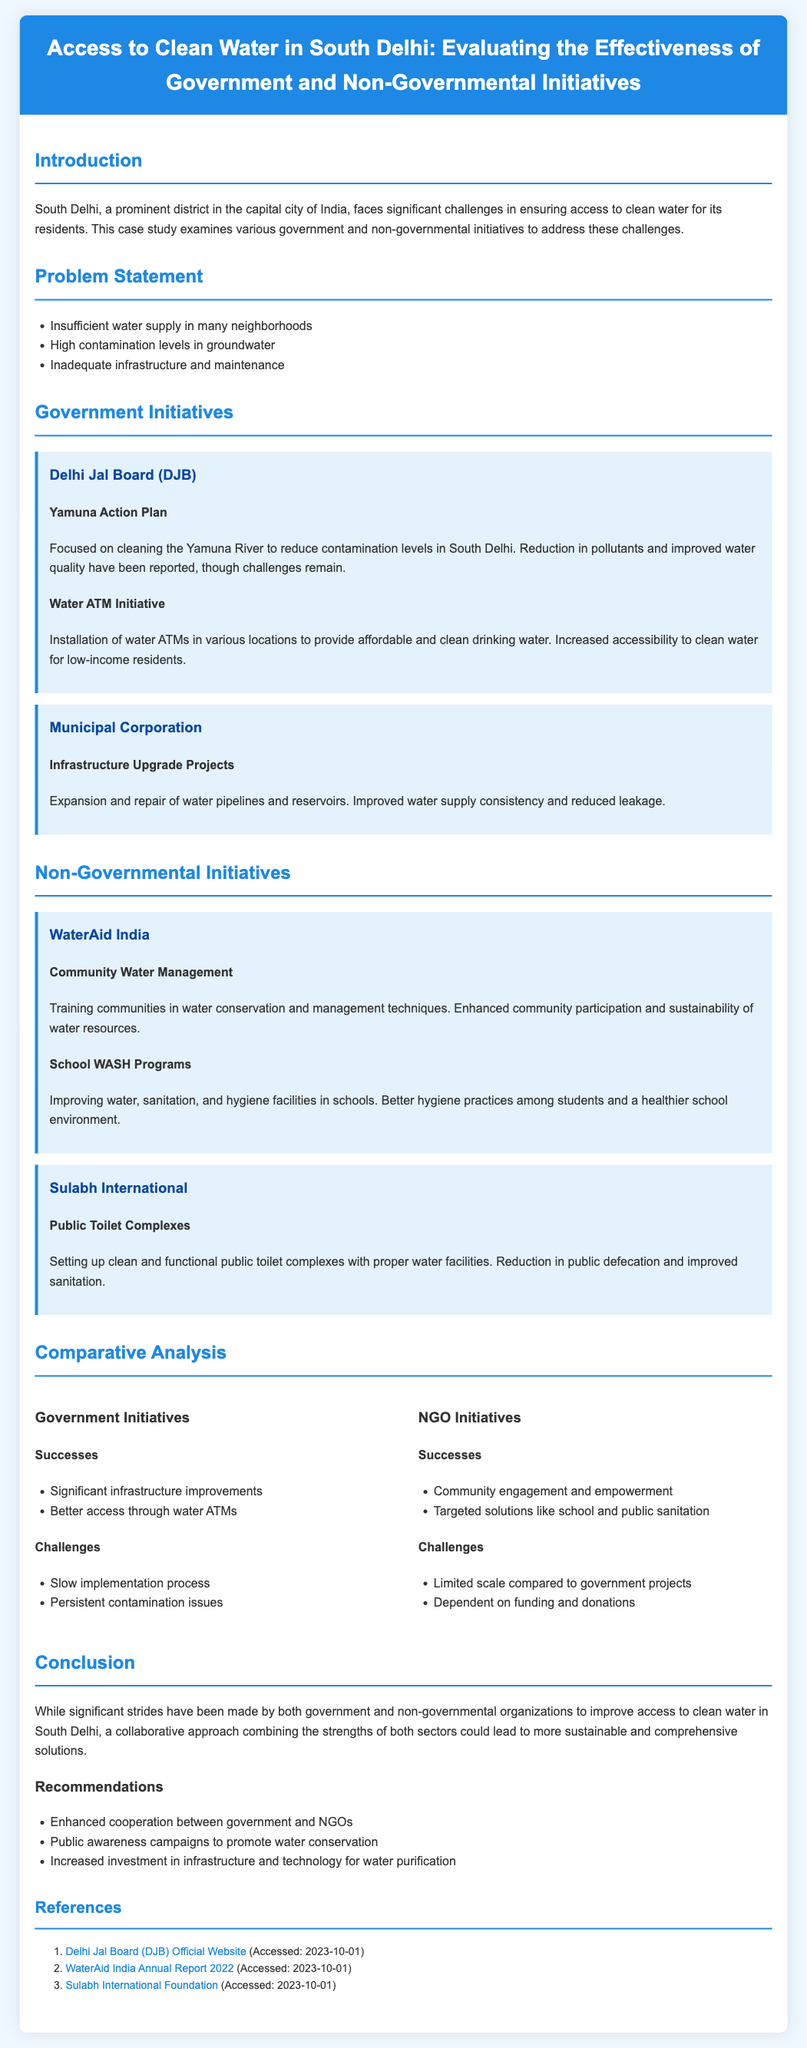what is the main focus of the Yamuna Action Plan? The Yamuna Action Plan focuses on cleaning the Yamuna River to reduce contamination levels in South Delhi.
Answer: cleaning the Yamuna River what organization implemented the Water ATM Initiative? The Water ATM Initiative was implemented by the Delhi Jal Board.
Answer: Delhi Jal Board which NGO is associated with School WASH Programs? The NGO associated with School WASH Programs is WaterAid India.
Answer: WaterAid India what is a major challenge faced by government initiatives mentioned in the case study? A major challenge is the persistent contamination issues.
Answer: persistent contamination issues what type of facilities does Sulabh International focus on? Sulabh International focuses on clean and functional public toilet complexes.
Answer: public toilet complexes how does the case study suggest enhancing cooperation for clean water access? The case study suggests enhanced cooperation between government and NGOs.
Answer: enhanced cooperation between government and NGOs what was one of the successes of NGO initiatives according to the analysis? One success of NGO initiatives is community engagement and empowerment.
Answer: community engagement and empowerment what year was the WaterAid India Annual Report accessed? The WaterAid India Annual Report was accessed in 2023.
Answer: 2023 what are the two types of initiatives evaluated in this case study? The two types of initiatives are government and non-governmental initiatives.
Answer: government and non-governmental initiatives 